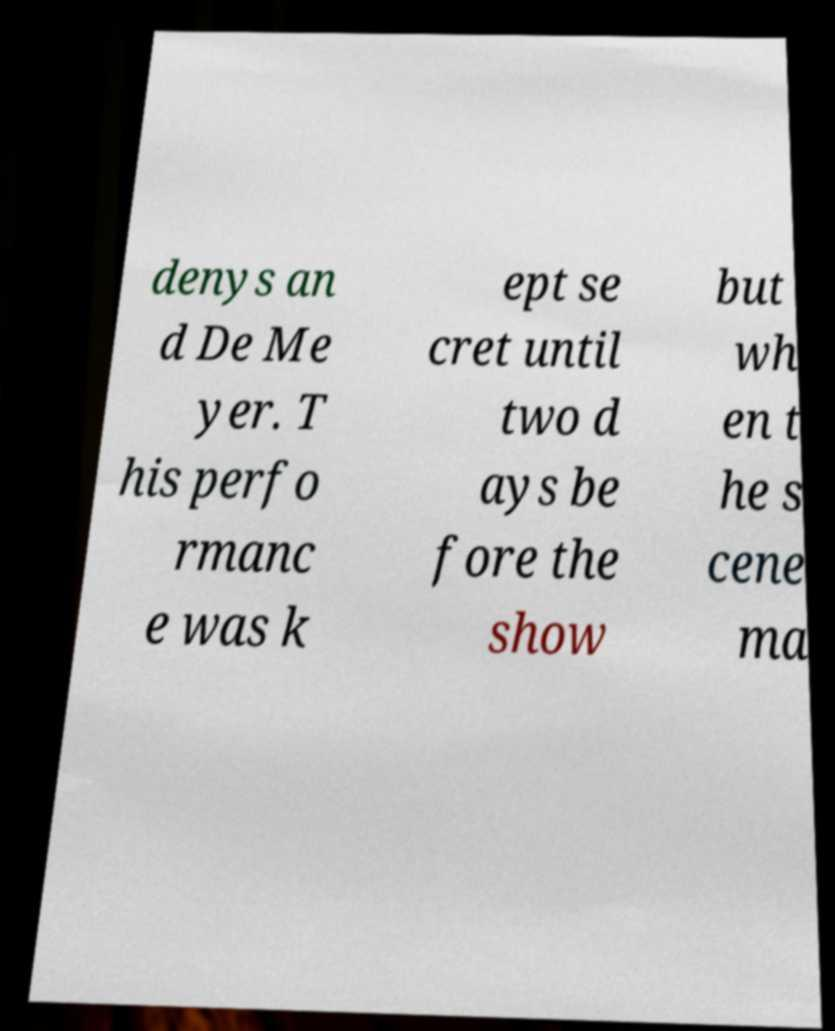For documentation purposes, I need the text within this image transcribed. Could you provide that? denys an d De Me yer. T his perfo rmanc e was k ept se cret until two d ays be fore the show but wh en t he s cene ma 